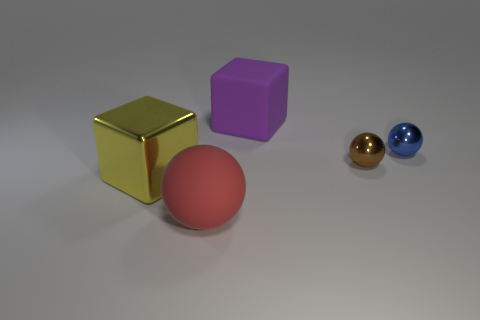There is a big matte thing right of the large sphere; is it the same color as the shiny cube? no 